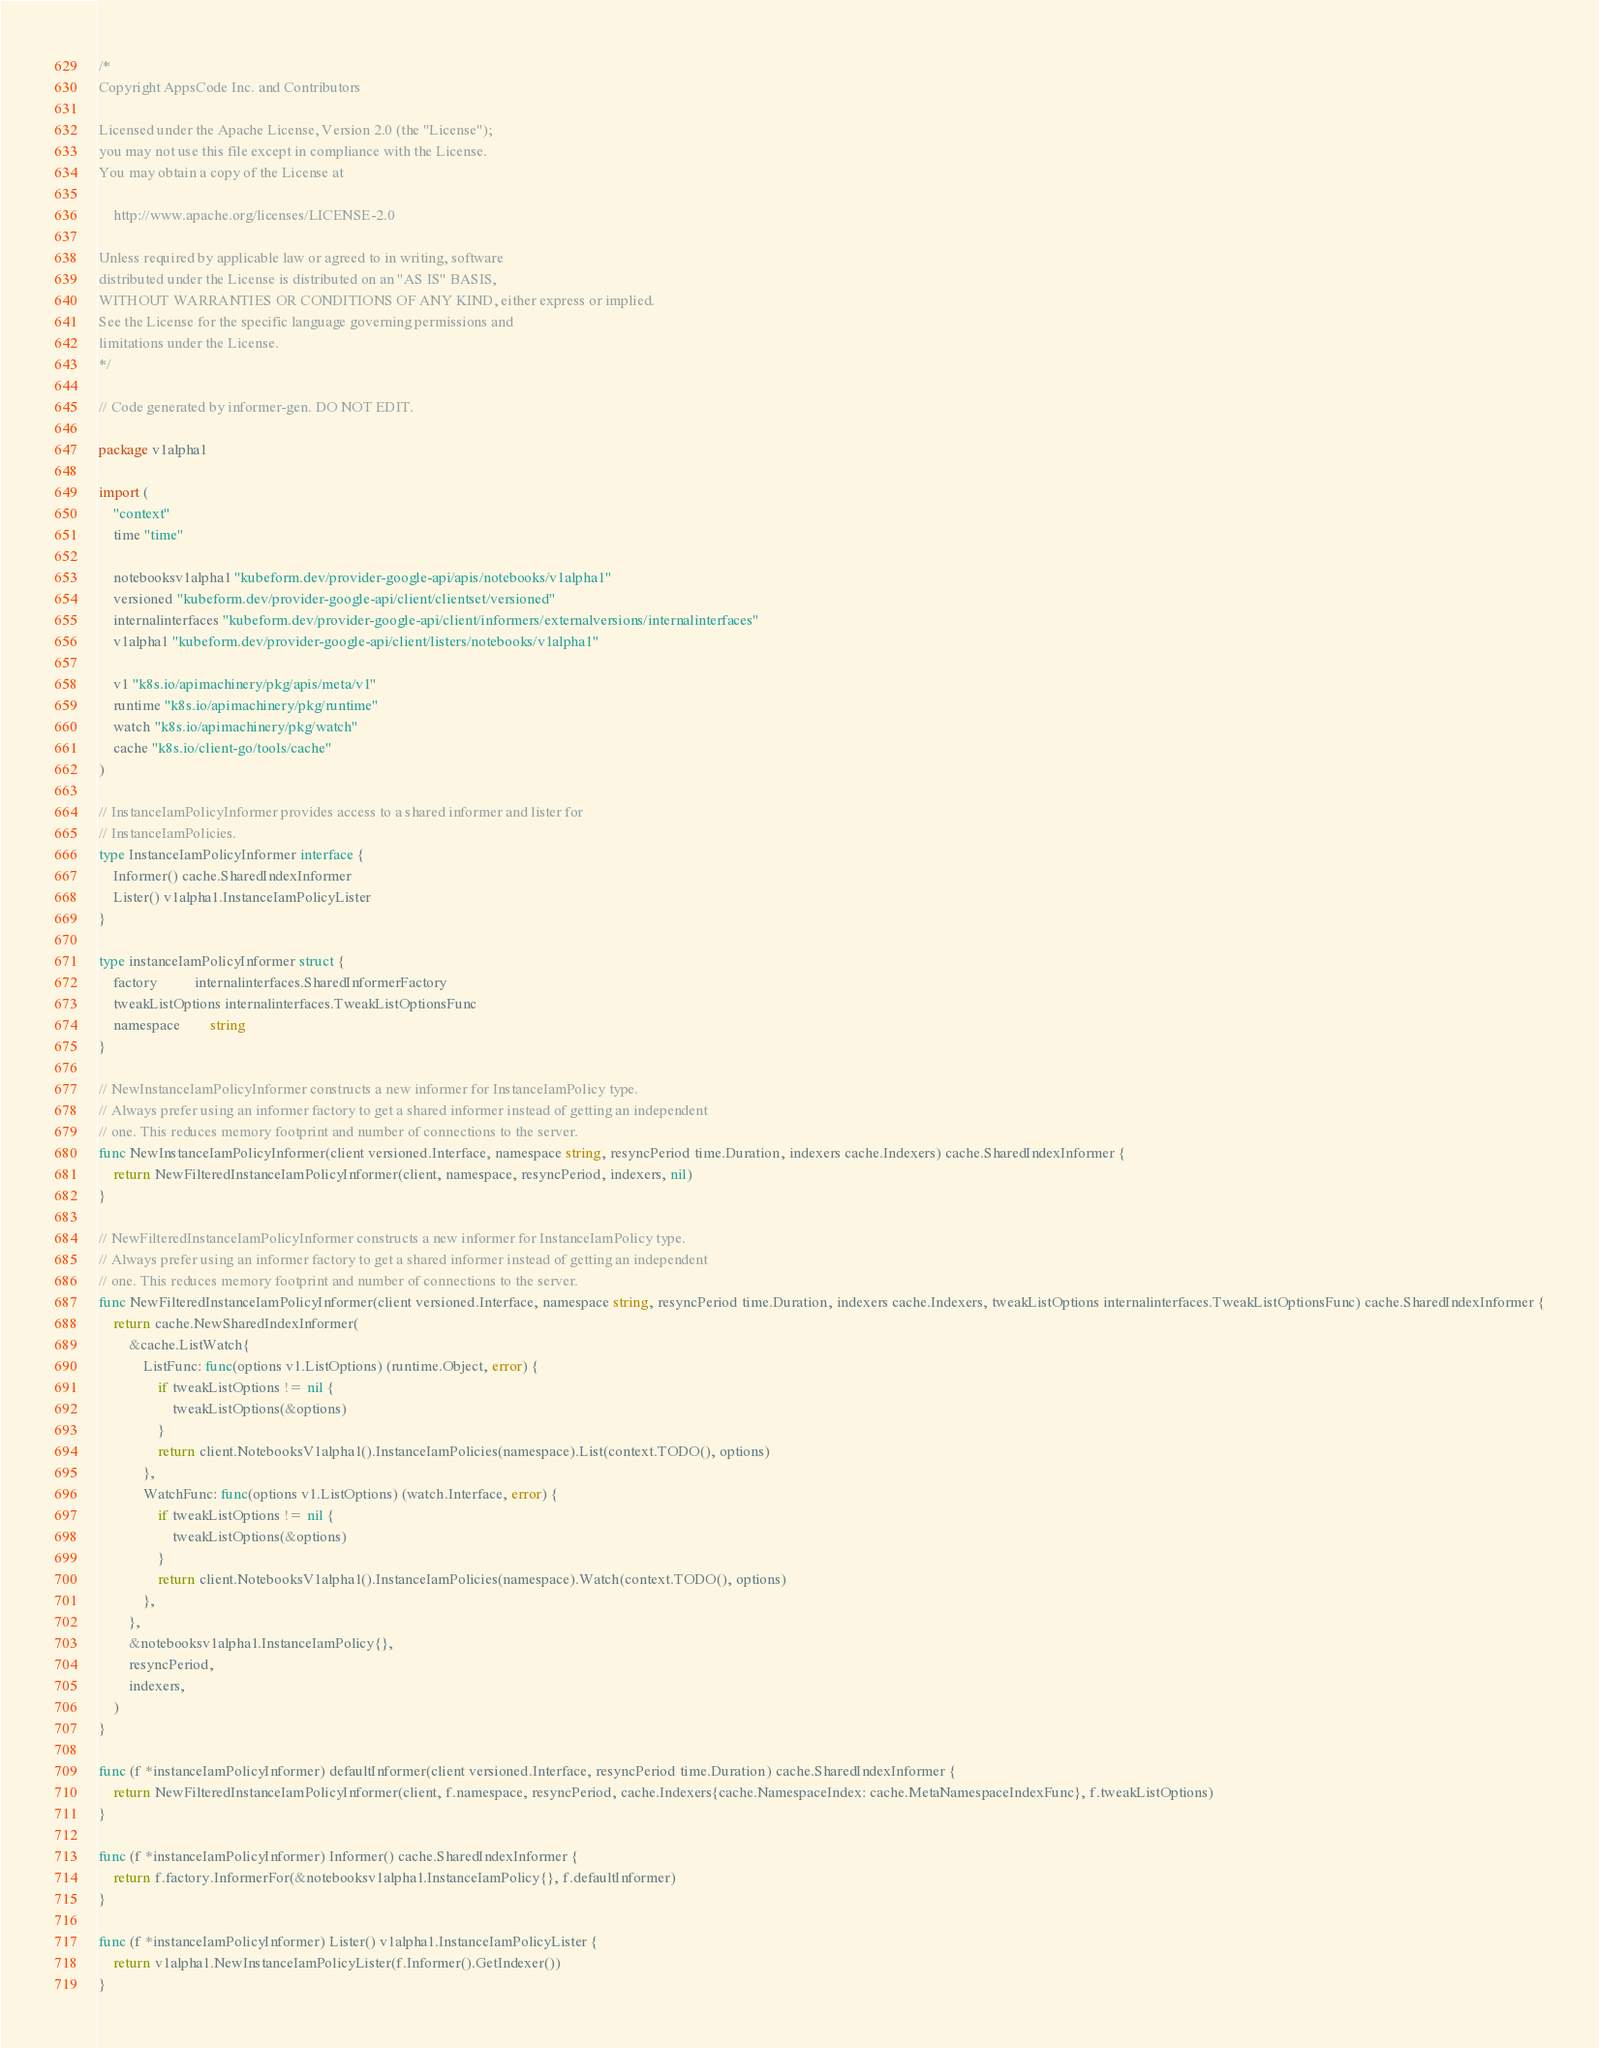Convert code to text. <code><loc_0><loc_0><loc_500><loc_500><_Go_>/*
Copyright AppsCode Inc. and Contributors

Licensed under the Apache License, Version 2.0 (the "License");
you may not use this file except in compliance with the License.
You may obtain a copy of the License at

    http://www.apache.org/licenses/LICENSE-2.0

Unless required by applicable law or agreed to in writing, software
distributed under the License is distributed on an "AS IS" BASIS,
WITHOUT WARRANTIES OR CONDITIONS OF ANY KIND, either express or implied.
See the License for the specific language governing permissions and
limitations under the License.
*/

// Code generated by informer-gen. DO NOT EDIT.

package v1alpha1

import (
	"context"
	time "time"

	notebooksv1alpha1 "kubeform.dev/provider-google-api/apis/notebooks/v1alpha1"
	versioned "kubeform.dev/provider-google-api/client/clientset/versioned"
	internalinterfaces "kubeform.dev/provider-google-api/client/informers/externalversions/internalinterfaces"
	v1alpha1 "kubeform.dev/provider-google-api/client/listers/notebooks/v1alpha1"

	v1 "k8s.io/apimachinery/pkg/apis/meta/v1"
	runtime "k8s.io/apimachinery/pkg/runtime"
	watch "k8s.io/apimachinery/pkg/watch"
	cache "k8s.io/client-go/tools/cache"
)

// InstanceIamPolicyInformer provides access to a shared informer and lister for
// InstanceIamPolicies.
type InstanceIamPolicyInformer interface {
	Informer() cache.SharedIndexInformer
	Lister() v1alpha1.InstanceIamPolicyLister
}

type instanceIamPolicyInformer struct {
	factory          internalinterfaces.SharedInformerFactory
	tweakListOptions internalinterfaces.TweakListOptionsFunc
	namespace        string
}

// NewInstanceIamPolicyInformer constructs a new informer for InstanceIamPolicy type.
// Always prefer using an informer factory to get a shared informer instead of getting an independent
// one. This reduces memory footprint and number of connections to the server.
func NewInstanceIamPolicyInformer(client versioned.Interface, namespace string, resyncPeriod time.Duration, indexers cache.Indexers) cache.SharedIndexInformer {
	return NewFilteredInstanceIamPolicyInformer(client, namespace, resyncPeriod, indexers, nil)
}

// NewFilteredInstanceIamPolicyInformer constructs a new informer for InstanceIamPolicy type.
// Always prefer using an informer factory to get a shared informer instead of getting an independent
// one. This reduces memory footprint and number of connections to the server.
func NewFilteredInstanceIamPolicyInformer(client versioned.Interface, namespace string, resyncPeriod time.Duration, indexers cache.Indexers, tweakListOptions internalinterfaces.TweakListOptionsFunc) cache.SharedIndexInformer {
	return cache.NewSharedIndexInformer(
		&cache.ListWatch{
			ListFunc: func(options v1.ListOptions) (runtime.Object, error) {
				if tweakListOptions != nil {
					tweakListOptions(&options)
				}
				return client.NotebooksV1alpha1().InstanceIamPolicies(namespace).List(context.TODO(), options)
			},
			WatchFunc: func(options v1.ListOptions) (watch.Interface, error) {
				if tweakListOptions != nil {
					tweakListOptions(&options)
				}
				return client.NotebooksV1alpha1().InstanceIamPolicies(namespace).Watch(context.TODO(), options)
			},
		},
		&notebooksv1alpha1.InstanceIamPolicy{},
		resyncPeriod,
		indexers,
	)
}

func (f *instanceIamPolicyInformer) defaultInformer(client versioned.Interface, resyncPeriod time.Duration) cache.SharedIndexInformer {
	return NewFilteredInstanceIamPolicyInformer(client, f.namespace, resyncPeriod, cache.Indexers{cache.NamespaceIndex: cache.MetaNamespaceIndexFunc}, f.tweakListOptions)
}

func (f *instanceIamPolicyInformer) Informer() cache.SharedIndexInformer {
	return f.factory.InformerFor(&notebooksv1alpha1.InstanceIamPolicy{}, f.defaultInformer)
}

func (f *instanceIamPolicyInformer) Lister() v1alpha1.InstanceIamPolicyLister {
	return v1alpha1.NewInstanceIamPolicyLister(f.Informer().GetIndexer())
}
</code> 